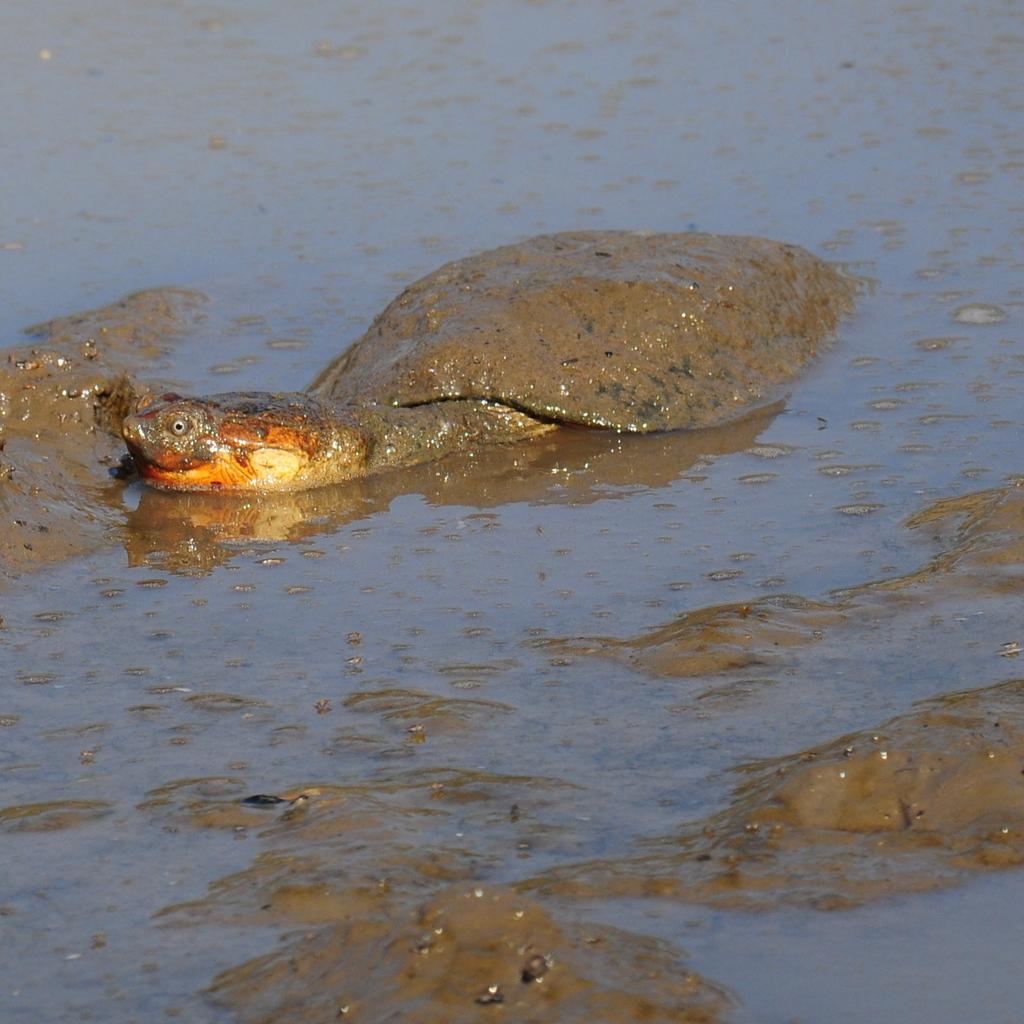Can you describe this image briefly? There is a tortoise in the water, near wet mud. 